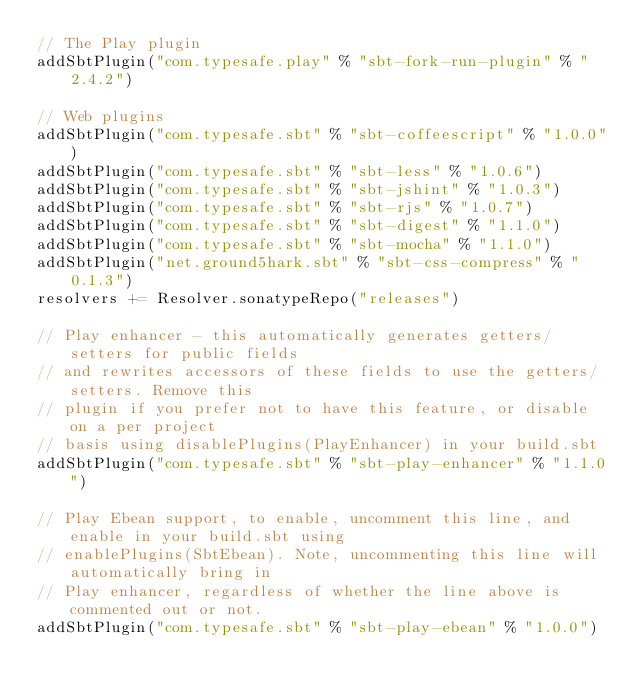<code> <loc_0><loc_0><loc_500><loc_500><_Scala_>// The Play plugin
addSbtPlugin("com.typesafe.play" % "sbt-fork-run-plugin" % "2.4.2")

// Web plugins
addSbtPlugin("com.typesafe.sbt" % "sbt-coffeescript" % "1.0.0")
addSbtPlugin("com.typesafe.sbt" % "sbt-less" % "1.0.6")
addSbtPlugin("com.typesafe.sbt" % "sbt-jshint" % "1.0.3")
addSbtPlugin("com.typesafe.sbt" % "sbt-rjs" % "1.0.7")
addSbtPlugin("com.typesafe.sbt" % "sbt-digest" % "1.1.0")
addSbtPlugin("com.typesafe.sbt" % "sbt-mocha" % "1.1.0")
addSbtPlugin("net.ground5hark.sbt" % "sbt-css-compress" % "0.1.3")
resolvers += Resolver.sonatypeRepo("releases")

// Play enhancer - this automatically generates getters/setters for public fields
// and rewrites accessors of these fields to use the getters/setters. Remove this
// plugin if you prefer not to have this feature, or disable on a per project
// basis using disablePlugins(PlayEnhancer) in your build.sbt
addSbtPlugin("com.typesafe.sbt" % "sbt-play-enhancer" % "1.1.0")

// Play Ebean support, to enable, uncomment this line, and enable in your build.sbt using
// enablePlugins(SbtEbean). Note, uncommenting this line will automatically bring in
// Play enhancer, regardless of whether the line above is commented out or not.
addSbtPlugin("com.typesafe.sbt" % "sbt-play-ebean" % "1.0.0")
</code> 